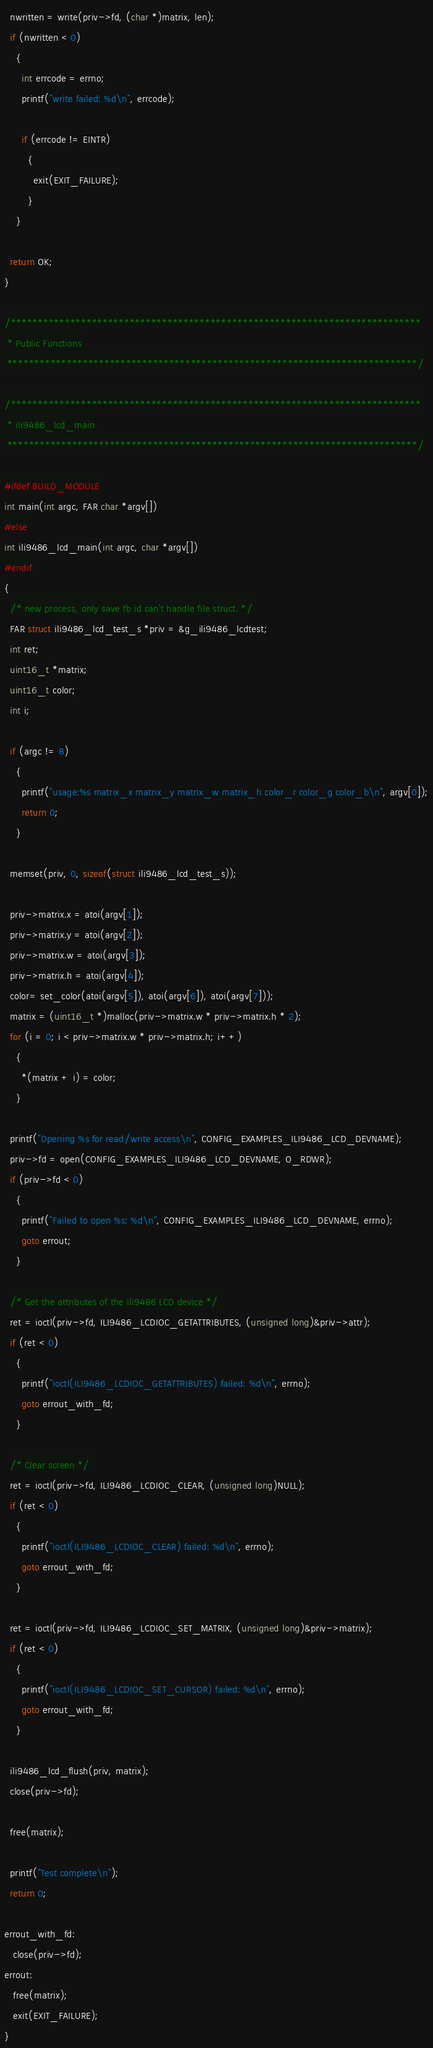Convert code to text. <code><loc_0><loc_0><loc_500><loc_500><_C_>  nwritten = write(priv->fd, (char *)matrix, len);
  if (nwritten < 0)
    {
      int errcode = errno;
      printf("write failed: %d\n", errcode);

      if (errcode != EINTR)
        {
          exit(EXIT_FAILURE);
        }
    }

  return OK;
}

/****************************************************************************
 * Public Functions
 ****************************************************************************/

/****************************************************************************
 * ili9486_lcd_main
 ****************************************************************************/

#ifdef BUILD_MODULE
int main(int argc, FAR char *argv[])
#else
int ili9486_lcd_main(int argc, char *argv[])
#endif
{
  /* new process, only save fb id can't handle file struct. */
  FAR struct ili9486_lcd_test_s *priv = &g_ili9486_lcdtest;
  int ret;
  uint16_t *matrix;
  uint16_t color;
  int i;

  if (argc != 8)
    {
      printf("usage:%s matrix_x matrix_y matrix_w matrix_h color_r color_g color_b\n", argv[0]);
      return 0;
    }

  memset(priv, 0, sizeof(struct ili9486_lcd_test_s));

  priv->matrix.x = atoi(argv[1]);
  priv->matrix.y = atoi(argv[2]);
  priv->matrix.w = atoi(argv[3]);
  priv->matrix.h = atoi(argv[4]);
  color= set_color(atoi(argv[5]), atoi(argv[6]), atoi(argv[7]));
  matrix = (uint16_t *)malloc(priv->matrix.w * priv->matrix.h * 2);
  for (i = 0; i < priv->matrix.w * priv->matrix.h; i++)
    {
      *(matrix + i) = color;
    }

  printf("Opening %s for read/write access\n", CONFIG_EXAMPLES_ILI9486_LCD_DEVNAME);
  priv->fd = open(CONFIG_EXAMPLES_ILI9486_LCD_DEVNAME, O_RDWR);
  if (priv->fd < 0)
    {
      printf("Failed to open %s: %d\n", CONFIG_EXAMPLES_ILI9486_LCD_DEVNAME, errno);
      goto errout;
    }

  /* Get the attributes of the Ili9486 LCD device */
  ret = ioctl(priv->fd, ILI9486_LCDIOC_GETATTRIBUTES, (unsigned long)&priv->attr);
  if (ret < 0)
    {
      printf("ioctl(ILI9486_LCDIOC_GETATTRIBUTES) failed: %d\n", errno);
      goto errout_with_fd;
    }

  /* Clear screen */
  ret = ioctl(priv->fd, ILI9486_LCDIOC_CLEAR, (unsigned long)NULL);
  if (ret < 0)
    {
      printf("ioctl(ILI9486_LCDIOC_CLEAR) failed: %d\n", errno);
      goto errout_with_fd;
    }

  ret = ioctl(priv->fd, ILI9486_LCDIOC_SET_MATRIX, (unsigned long)&priv->matrix);
  if (ret < 0)
    {
      printf("ioctl(ILI9486_LCDIOC_SET_CURSOR) failed: %d\n", errno);
      goto errout_with_fd;
    }

  ili9486_lcd_flush(priv, matrix);
  close(priv->fd);

  free(matrix);

  printf("Test complete\n");
  return 0;

errout_with_fd:
   close(priv->fd);
errout:
   free(matrix);
   exit(EXIT_FAILURE);
}
</code> 